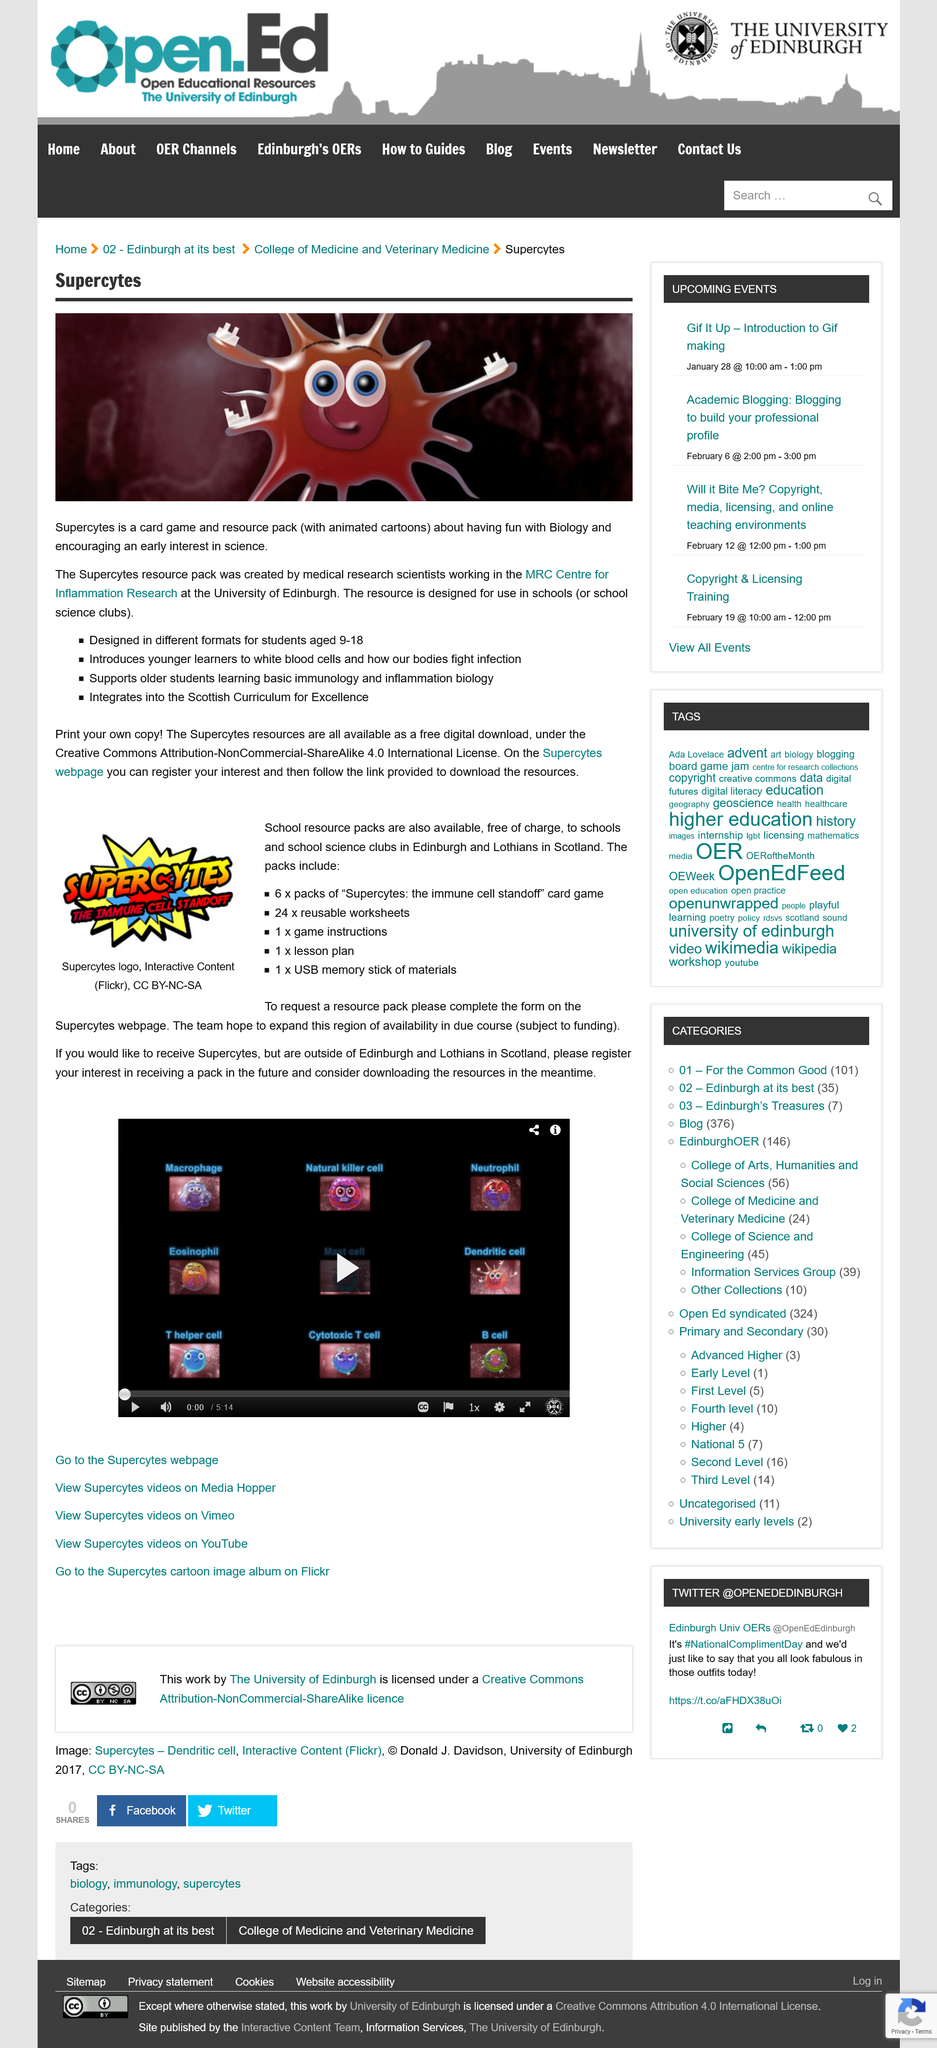Highlight a few significant elements in this photo. Supercytes is a card game that involves strategic decision-making and skillful play. Yes, Supercytes has a webpage. The card game was designed for students aged 9 to 18. The name of this game is Supercytes, and it is called Supercytes. The packs include 24 reusable worksheets. 